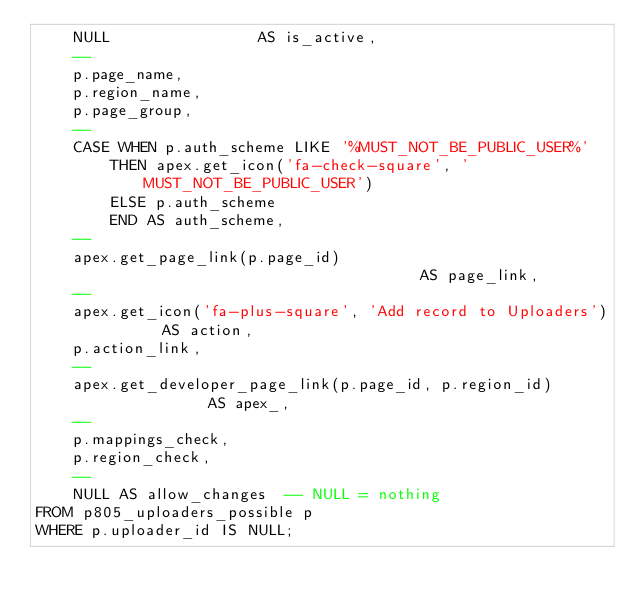<code> <loc_0><loc_0><loc_500><loc_500><_SQL_>    NULL                AS is_active,
    --
    p.page_name,
    p.region_name,
    p.page_group,
    --
    CASE WHEN p.auth_scheme LIKE '%MUST_NOT_BE_PUBLIC_USER%'
        THEN apex.get_icon('fa-check-square', 'MUST_NOT_BE_PUBLIC_USER')
        ELSE p.auth_scheme
        END AS auth_scheme,
    --
    apex.get_page_link(p.page_id)                                   AS page_link,
    --
    apex.get_icon('fa-plus-square', 'Add record to Uploaders')      AS action,
    p.action_link,
    --
    apex.get_developer_page_link(p.page_id, p.region_id)            AS apex_,
    --
    p.mappings_check,
    p.region_check,
    --
    NULL AS allow_changes  -- NULL = nothing
FROM p805_uploaders_possible p
WHERE p.uploader_id IS NULL;

</code> 